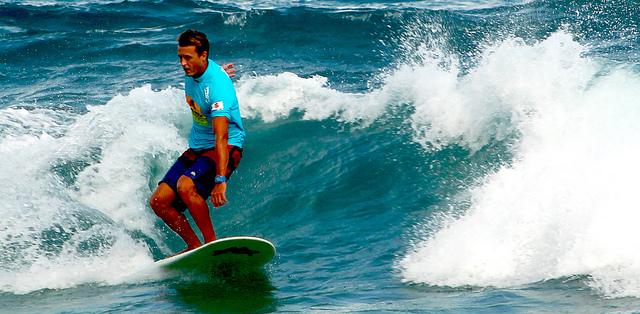Are both of the surfer's feet on the board?
Keep it brief. Yes. What colors does the man wear?
Quick response, please. Blue and red. What is the man doing?
Give a very brief answer. Surfing. What color is the board?
Answer briefly. Green. 